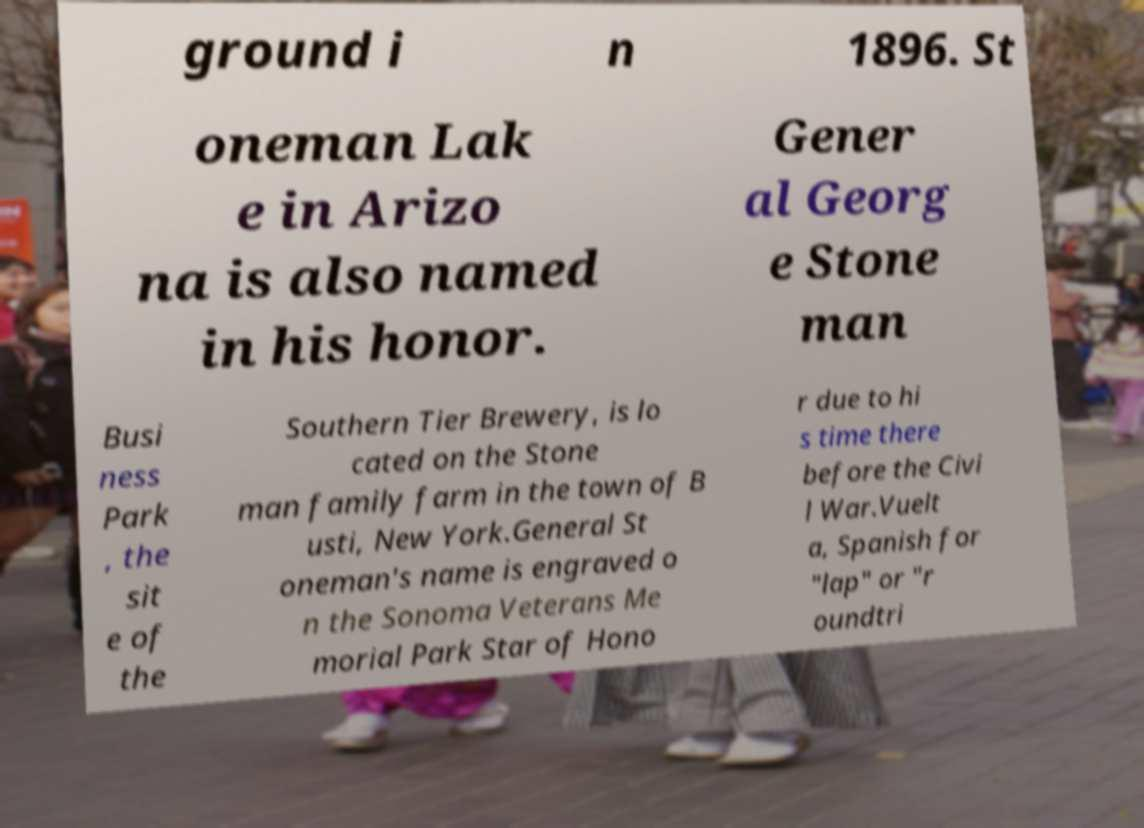What messages or text are displayed in this image? I need them in a readable, typed format. ground i n 1896. St oneman Lak e in Arizo na is also named in his honor. Gener al Georg e Stone man Busi ness Park , the sit e of the Southern Tier Brewery, is lo cated on the Stone man family farm in the town of B usti, New York.General St oneman's name is engraved o n the Sonoma Veterans Me morial Park Star of Hono r due to hi s time there before the Civi l War.Vuelt a, Spanish for "lap" or "r oundtri 